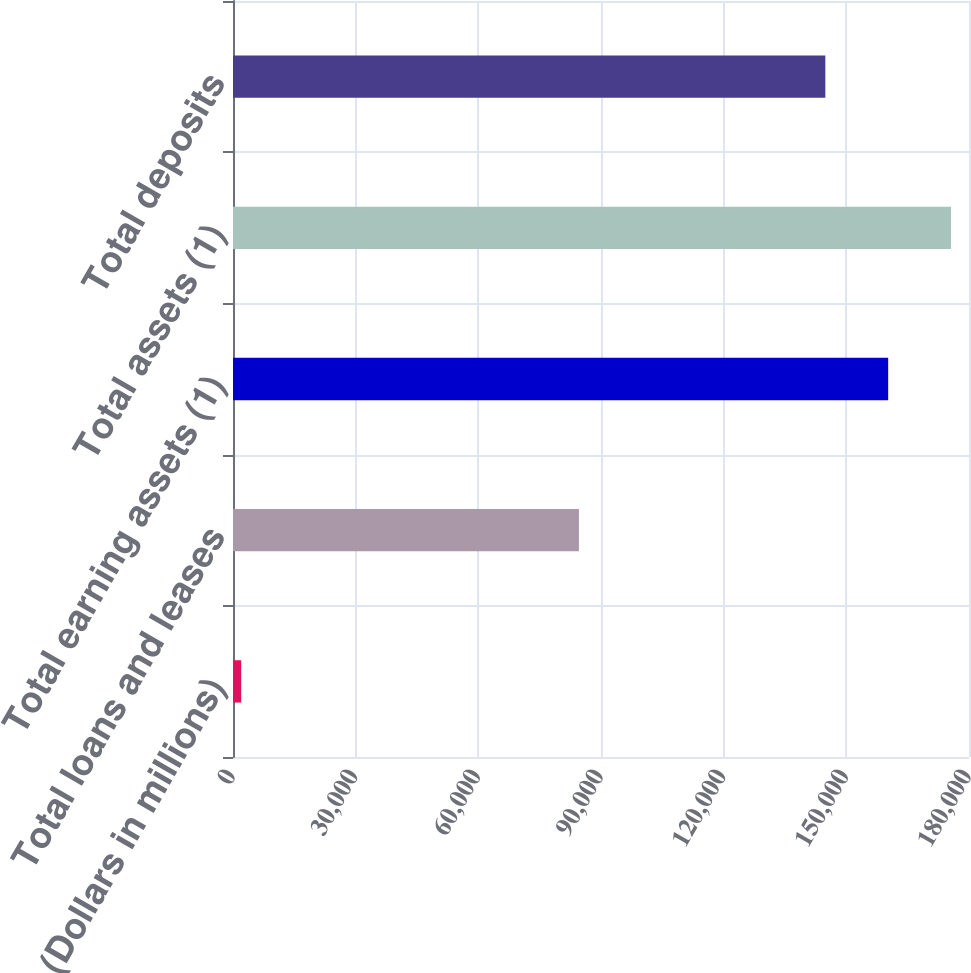<chart> <loc_0><loc_0><loc_500><loc_500><bar_chart><fcel>(Dollars in millions)<fcel>Total loans and leases<fcel>Total earning assets (1)<fcel>Total assets (1)<fcel>Total deposits<nl><fcel>2007<fcel>84600<fcel>160233<fcel>175600<fcel>144865<nl></chart> 